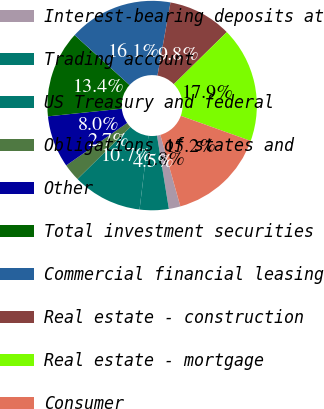Convert chart. <chart><loc_0><loc_0><loc_500><loc_500><pie_chart><fcel>Interest-bearing deposits at<fcel>Trading account<fcel>US Treasury and federal<fcel>Obligations of states and<fcel>Other<fcel>Total investment securities<fcel>Commercial financial leasing<fcel>Real estate - construction<fcel>Real estate - mortgage<fcel>Consumer<nl><fcel>1.79%<fcel>4.47%<fcel>10.71%<fcel>2.69%<fcel>8.04%<fcel>13.39%<fcel>16.06%<fcel>9.82%<fcel>17.85%<fcel>15.17%<nl></chart> 